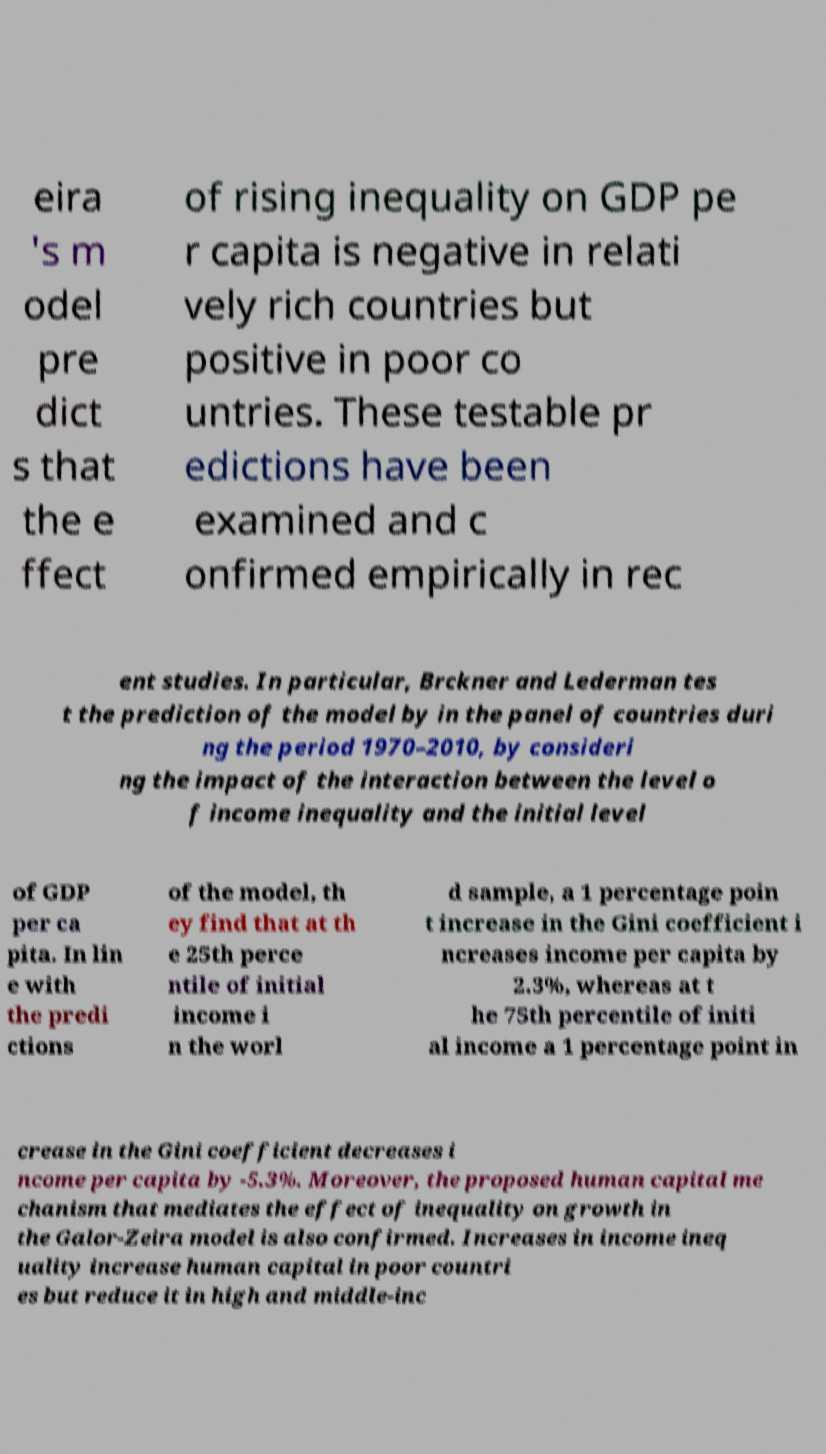Can you accurately transcribe the text from the provided image for me? eira 's m odel pre dict s that the e ffect of rising inequality on GDP pe r capita is negative in relati vely rich countries but positive in poor co untries. These testable pr edictions have been examined and c onfirmed empirically in rec ent studies. In particular, Brckner and Lederman tes t the prediction of the model by in the panel of countries duri ng the period 1970–2010, by consideri ng the impact of the interaction between the level o f income inequality and the initial level of GDP per ca pita. In lin e with the predi ctions of the model, th ey find that at th e 25th perce ntile of initial income i n the worl d sample, a 1 percentage poin t increase in the Gini coefficient i ncreases income per capita by 2.3%, whereas at t he 75th percentile of initi al income a 1 percentage point in crease in the Gini coefficient decreases i ncome per capita by -5.3%. Moreover, the proposed human capital me chanism that mediates the effect of inequality on growth in the Galor-Zeira model is also confirmed. Increases in income ineq uality increase human capital in poor countri es but reduce it in high and middle-inc 